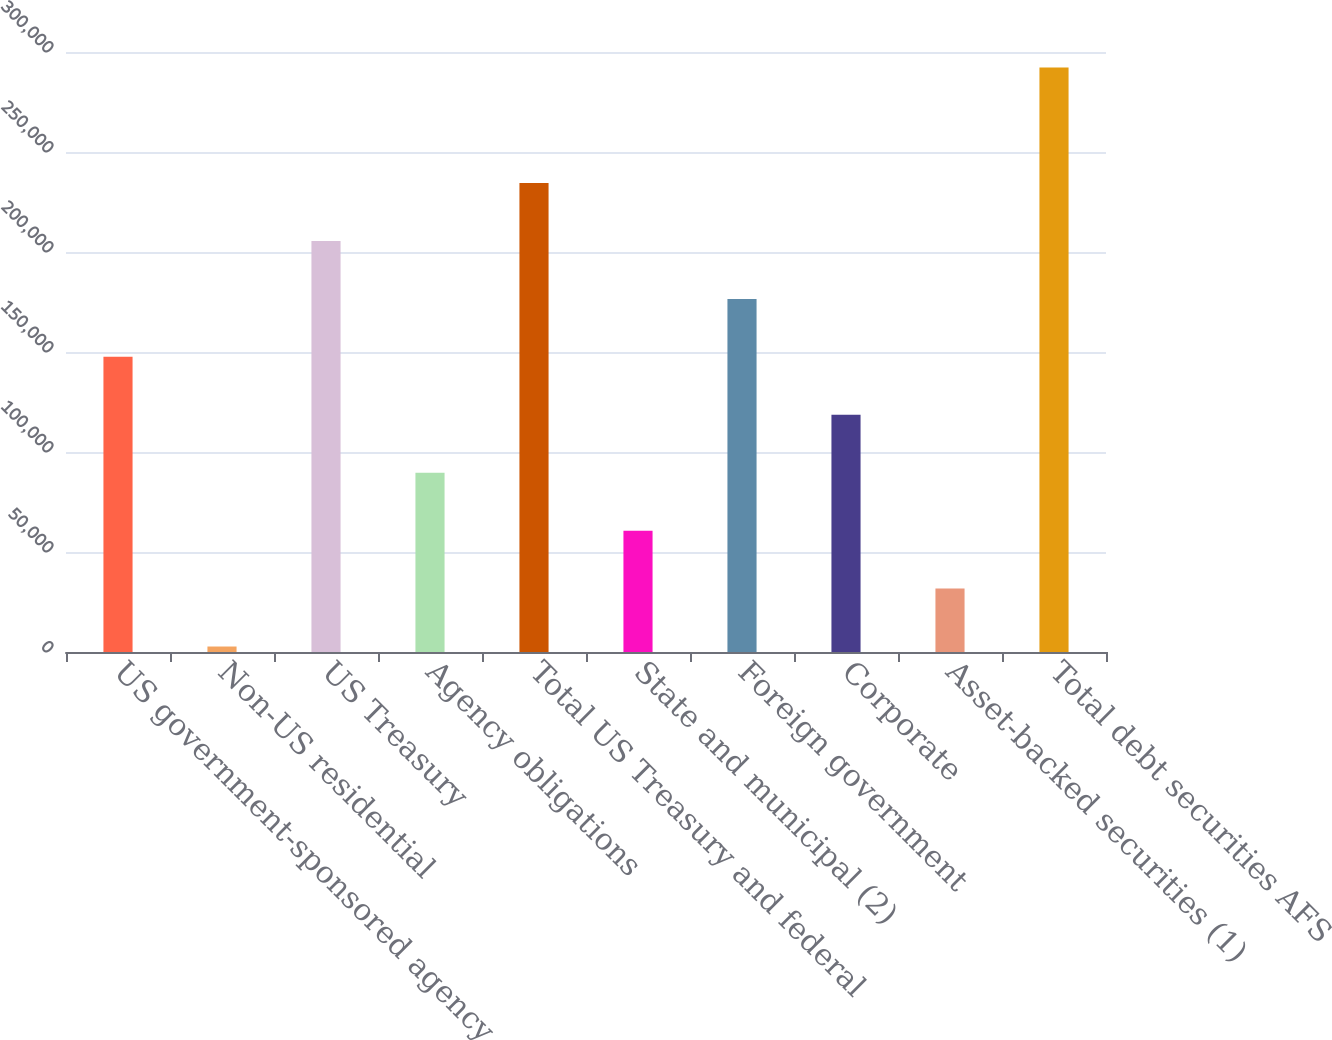Convert chart to OTSL. <chart><loc_0><loc_0><loc_500><loc_500><bar_chart><fcel>US government-sponsored agency<fcel>Non-US residential<fcel>US Treasury<fcel>Agency obligations<fcel>Total US Treasury and federal<fcel>State and municipal (2)<fcel>Foreign government<fcel>Corporate<fcel>Asset-backed securities (1)<fcel>Total debt securities AFS<nl><fcel>147575<fcel>2744<fcel>205507<fcel>89642.6<fcel>234474<fcel>60676.4<fcel>176541<fcel>118609<fcel>31710.2<fcel>292220<nl></chart> 